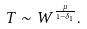Convert formula to latex. <formula><loc_0><loc_0><loc_500><loc_500>T \sim W ^ { \frac { \mu } { 1 - \delta _ { 1 } } } .</formula> 